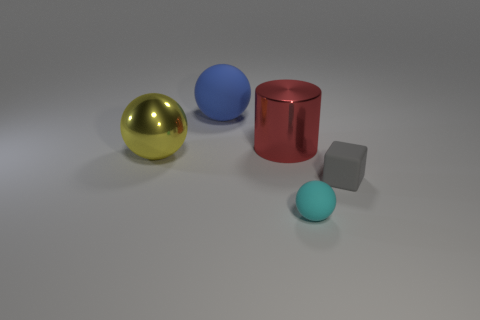What shape is the blue rubber thing that is the same size as the metal ball?
Make the answer very short. Sphere. There is a large matte sphere to the left of the tiny sphere to the right of the yellow metallic thing; what number of gray blocks are to the right of it?
Your answer should be very brief. 1. What is the color of the ball that is behind the gray object and on the right side of the big yellow object?
Provide a succinct answer. Blue. Is the size of the matte thing that is in front of the block the same as the large yellow ball?
Your answer should be very brief. No. Are there any gray metallic cylinders that have the same size as the yellow sphere?
Give a very brief answer. No. There is a blue thing that is the same size as the shiny ball; what is it made of?
Your answer should be very brief. Rubber. The matte thing that is both left of the block and in front of the blue matte sphere has what shape?
Offer a terse response. Sphere. There is a matte ball that is behind the rubber block; what color is it?
Ensure brevity in your answer.  Blue. What is the size of the object that is in front of the red metal thing and to the left of the red shiny cylinder?
Provide a short and direct response. Large. Are the block and the big object in front of the red thing made of the same material?
Provide a short and direct response. No. 